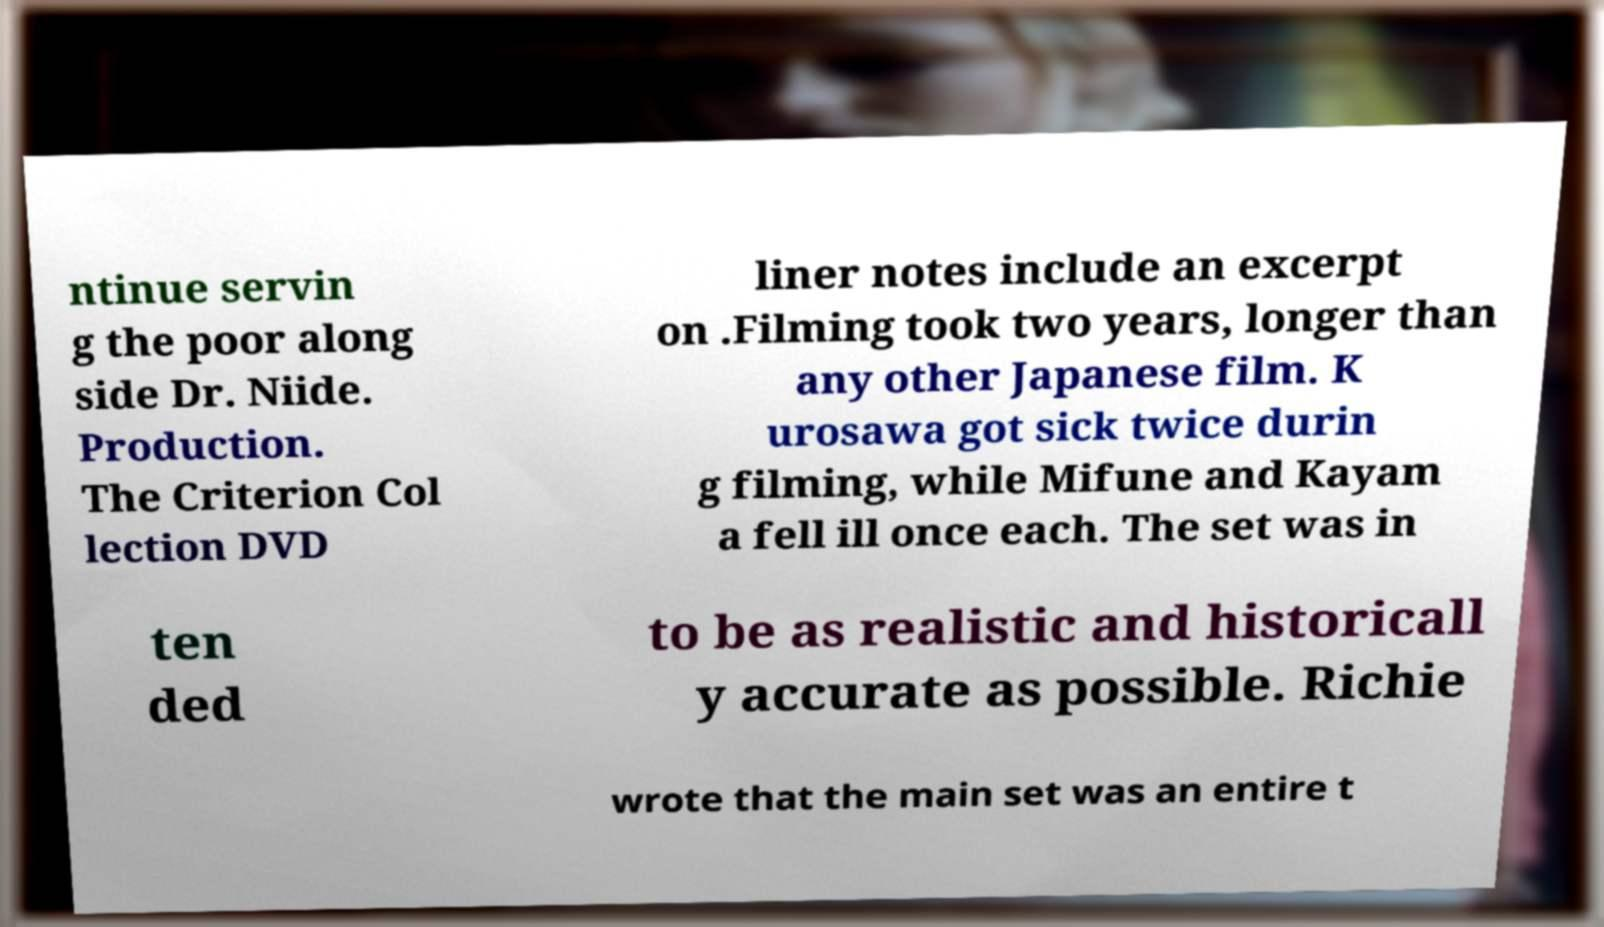Could you extract and type out the text from this image? ntinue servin g the poor along side Dr. Niide. Production. The Criterion Col lection DVD liner notes include an excerpt on .Filming took two years, longer than any other Japanese film. K urosawa got sick twice durin g filming, while Mifune and Kayam a fell ill once each. The set was in ten ded to be as realistic and historicall y accurate as possible. Richie wrote that the main set was an entire t 